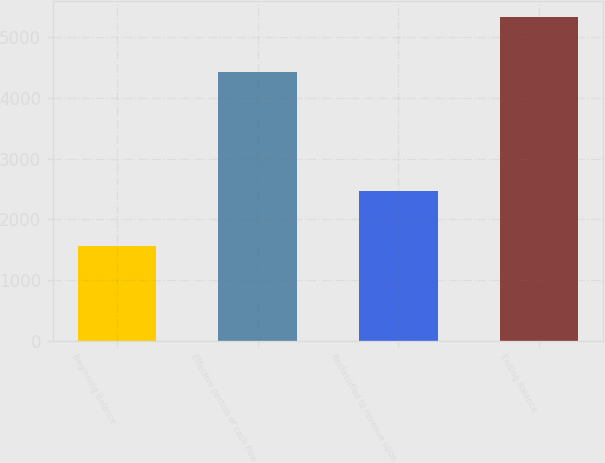<chart> <loc_0><loc_0><loc_500><loc_500><bar_chart><fcel>Beginning Balance<fcel>Effective portion of cash flow<fcel>Reclassified to revenue upon<fcel>Ending Balance<nl><fcel>1559<fcel>4428<fcel>2466<fcel>5335<nl></chart> 